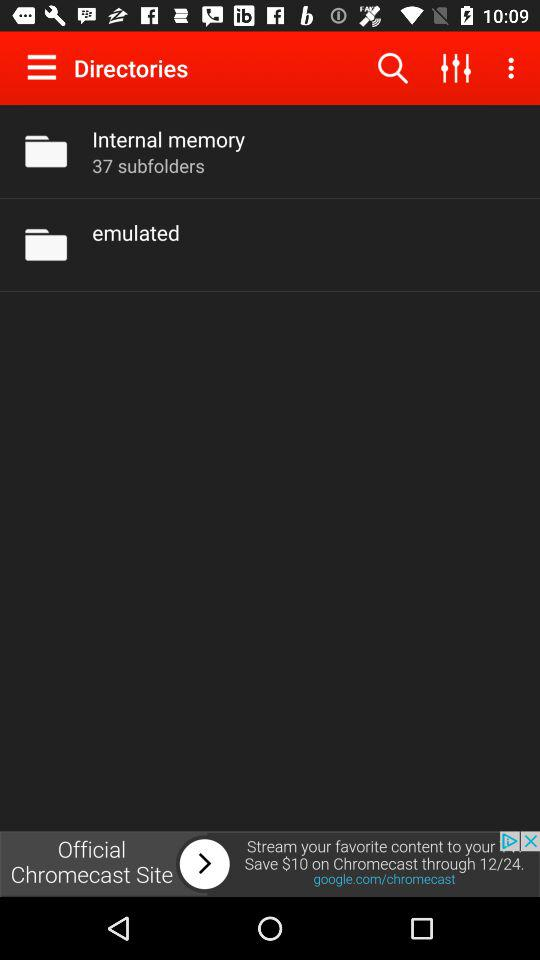How many subfolders are there in internal memory? There are 37 subfolders. 